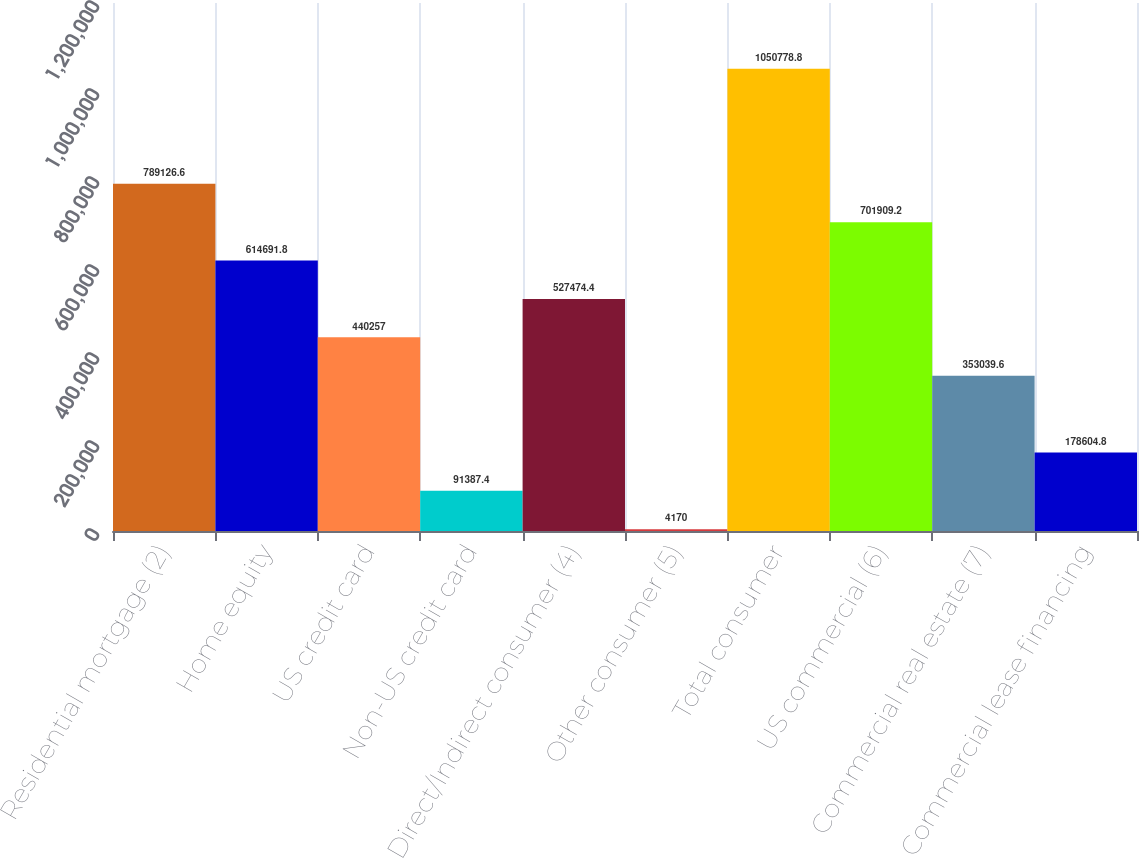<chart> <loc_0><loc_0><loc_500><loc_500><bar_chart><fcel>Residential mortgage (2)<fcel>Home equity<fcel>US credit card<fcel>Non-US credit card<fcel>Direct/Indirect consumer (4)<fcel>Other consumer (5)<fcel>Total consumer<fcel>US commercial (6)<fcel>Commercial real estate (7)<fcel>Commercial lease financing<nl><fcel>789127<fcel>614692<fcel>440257<fcel>91387.4<fcel>527474<fcel>4170<fcel>1.05078e+06<fcel>701909<fcel>353040<fcel>178605<nl></chart> 